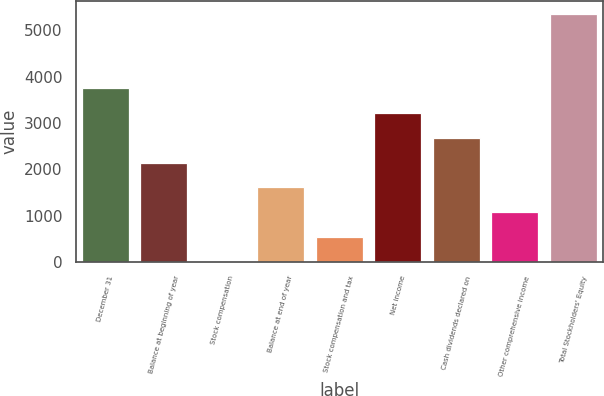Convert chart to OTSL. <chart><loc_0><loc_0><loc_500><loc_500><bar_chart><fcel>December 31<fcel>Balance at beginning of year<fcel>Stock compensation<fcel>Balance at end of year<fcel>Stock compensation and tax<fcel>Net income<fcel>Cash dividends declared on<fcel>Other comprehensive income<fcel>Total Stockholders' Equity<nl><fcel>3755.29<fcel>2146.18<fcel>0.7<fcel>1609.81<fcel>537.07<fcel>3218.92<fcel>2682.55<fcel>1073.44<fcel>5364.4<nl></chart> 